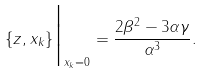Convert formula to latex. <formula><loc_0><loc_0><loc_500><loc_500>\{ z , x _ { k } \} \Big | _ { x _ { k } = 0 } = \frac { 2 \beta ^ { 2 } - 3 \alpha \gamma } { \alpha ^ { 3 } } .</formula> 